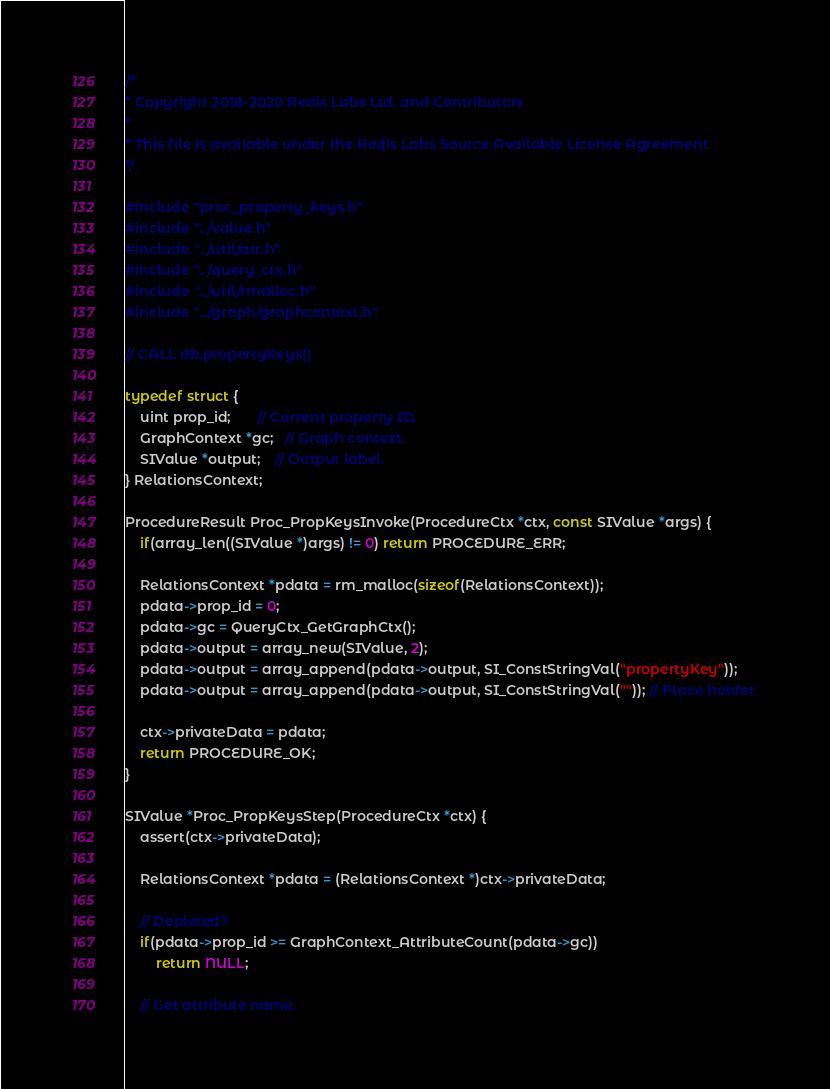Convert code to text. <code><loc_0><loc_0><loc_500><loc_500><_C_>/*
* Copyright 2018-2020 Redis Labs Ltd. and Contributors
*
* This file is available under the Redis Labs Source Available License Agreement
*/

#include "proc_property_keys.h"
#include "../value.h"
#include "../util/arr.h"
#include "../query_ctx.h"
#include "../util/rmalloc.h"
#include "../graph/graphcontext.h"

// CALL db.propertyKeys()

typedef struct {
	uint prop_id;       // Current property ID.
	GraphContext *gc;   // Graph context.
	SIValue *output;    // Output label.
} RelationsContext;

ProcedureResult Proc_PropKeysInvoke(ProcedureCtx *ctx, const SIValue *args) {
	if(array_len((SIValue *)args) != 0) return PROCEDURE_ERR;

	RelationsContext *pdata = rm_malloc(sizeof(RelationsContext));
	pdata->prop_id = 0;
	pdata->gc = QueryCtx_GetGraphCtx();
	pdata->output = array_new(SIValue, 2);
	pdata->output = array_append(pdata->output, SI_ConstStringVal("propertyKey"));
	pdata->output = array_append(pdata->output, SI_ConstStringVal("")); // Place holder.

	ctx->privateData = pdata;
	return PROCEDURE_OK;
}

SIValue *Proc_PropKeysStep(ProcedureCtx *ctx) {
	assert(ctx->privateData);

	RelationsContext *pdata = (RelationsContext *)ctx->privateData;

	// Depleted?
	if(pdata->prop_id >= GraphContext_AttributeCount(pdata->gc))
		return NULL;

	// Get attribute name.</code> 